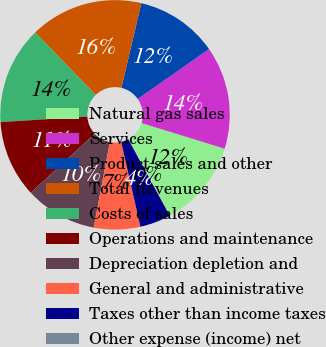Convert chart to OTSL. <chart><loc_0><loc_0><loc_500><loc_500><pie_chart><fcel>Natural gas sales<fcel>Services<fcel>Product sales and other<fcel>Total Revenues<fcel>Costs of sales<fcel>Operations and maintenance<fcel>Depreciation depletion and<fcel>General and administrative<fcel>Taxes other than income taxes<fcel>Other expense (income) net<nl><fcel>12.32%<fcel>14.49%<fcel>11.59%<fcel>15.94%<fcel>13.76%<fcel>10.87%<fcel>10.14%<fcel>6.53%<fcel>4.35%<fcel>0.01%<nl></chart> 